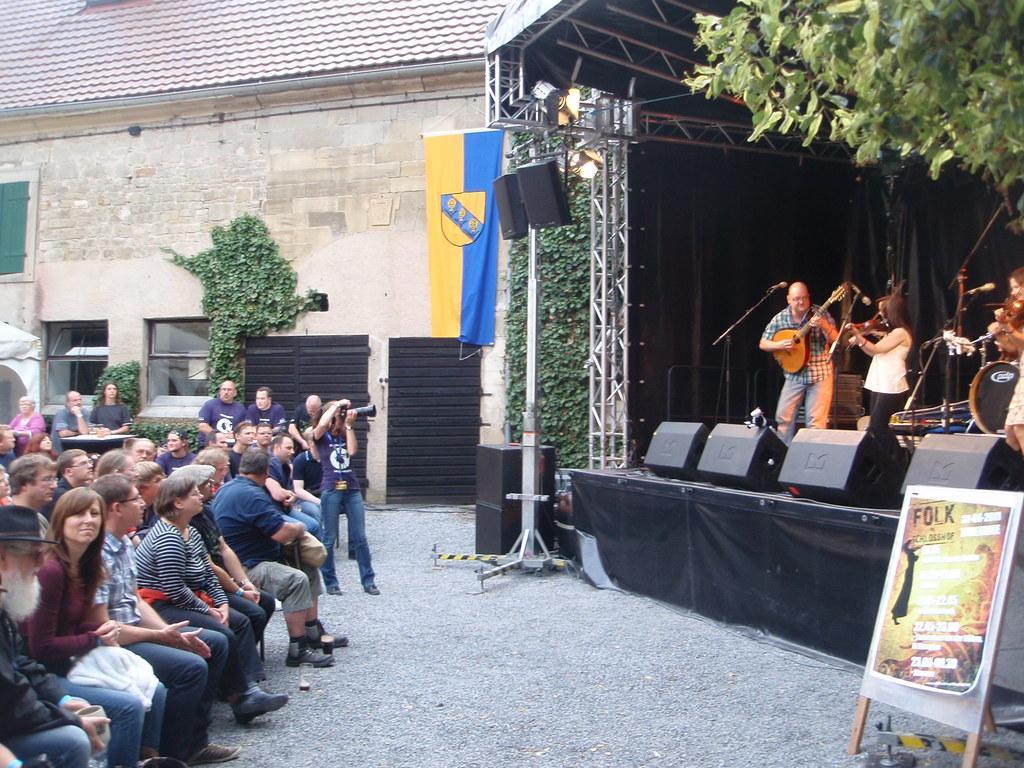In one or two sentences, can you explain what this image depicts? In this image we can see the stage, sound boxes, lights, some rods, miles with the stands. We can also see the people playing the musical instruments. On the left we can see some people standing and there are people sitting. We can also see the path, board, tree, flag and also the house with the windows, creepers and we can see a man in front of the table. 